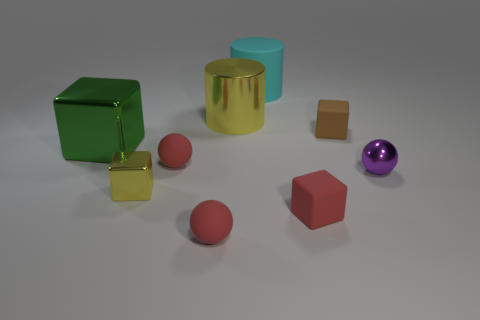Subtract all big metal cubes. How many cubes are left? 3 Subtract all red cubes. How many cubes are left? 3 Subtract all cylinders. How many objects are left? 7 Subtract 1 blocks. How many blocks are left? 3 Subtract all red spheres. How many yellow cylinders are left? 1 Subtract all blue matte things. Subtract all yellow blocks. How many objects are left? 8 Add 4 large cyan matte objects. How many large cyan matte objects are left? 5 Add 1 big yellow metallic cylinders. How many big yellow metallic cylinders exist? 2 Subtract 0 purple cylinders. How many objects are left? 9 Subtract all purple blocks. Subtract all blue cylinders. How many blocks are left? 4 